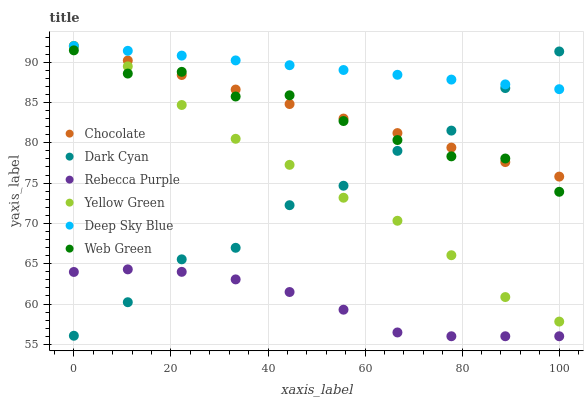Does Rebecca Purple have the minimum area under the curve?
Answer yes or no. Yes. Does Deep Sky Blue have the maximum area under the curve?
Answer yes or no. Yes. Does Web Green have the minimum area under the curve?
Answer yes or no. No. Does Web Green have the maximum area under the curve?
Answer yes or no. No. Is Deep Sky Blue the smoothest?
Answer yes or no. Yes. Is Web Green the roughest?
Answer yes or no. Yes. Is Chocolate the smoothest?
Answer yes or no. No. Is Chocolate the roughest?
Answer yes or no. No. Does Rebecca Purple have the lowest value?
Answer yes or no. Yes. Does Web Green have the lowest value?
Answer yes or no. No. Does Deep Sky Blue have the highest value?
Answer yes or no. Yes. Does Web Green have the highest value?
Answer yes or no. No. Is Rebecca Purple less than Yellow Green?
Answer yes or no. Yes. Is Chocolate greater than Rebecca Purple?
Answer yes or no. Yes. Does Yellow Green intersect Web Green?
Answer yes or no. Yes. Is Yellow Green less than Web Green?
Answer yes or no. No. Is Yellow Green greater than Web Green?
Answer yes or no. No. Does Rebecca Purple intersect Yellow Green?
Answer yes or no. No. 